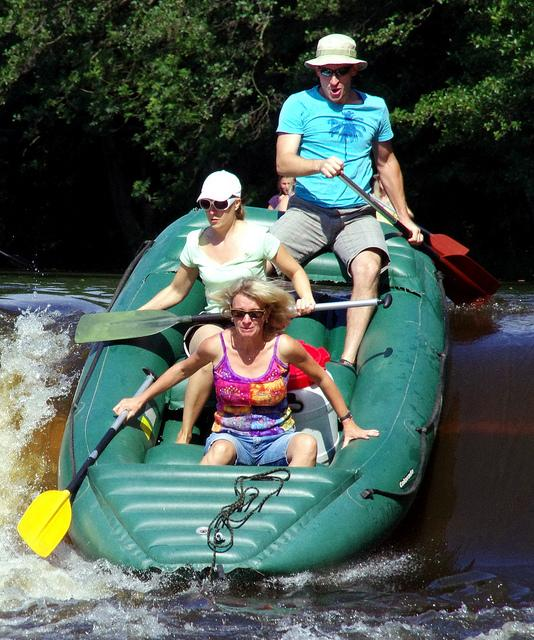What type of boat are they navigating the water on?

Choices:
A) fishing
B) raft
C) canoe
D) kayak raft 